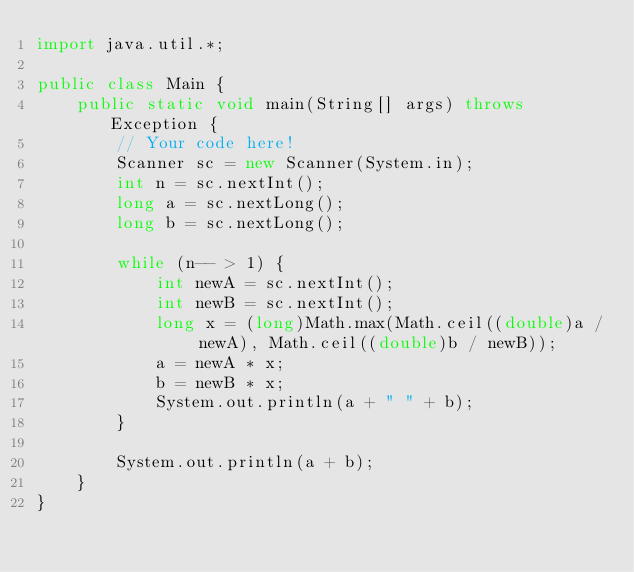Convert code to text. <code><loc_0><loc_0><loc_500><loc_500><_Java_>import java.util.*;

public class Main {
    public static void main(String[] args) throws Exception {
        // Your code here!
        Scanner sc = new Scanner(System.in);
        int n = sc.nextInt();
        long a = sc.nextLong();
        long b = sc.nextLong();
        
        while (n-- > 1) {
            int newA = sc.nextInt();
            int newB = sc.nextInt();
            long x = (long)Math.max(Math.ceil((double)a / newA), Math.ceil((double)b / newB));
            a = newA * x;
            b = newB * x;
            System.out.println(a + " " + b);
        }
        
        System.out.println(a + b);
    }
}</code> 